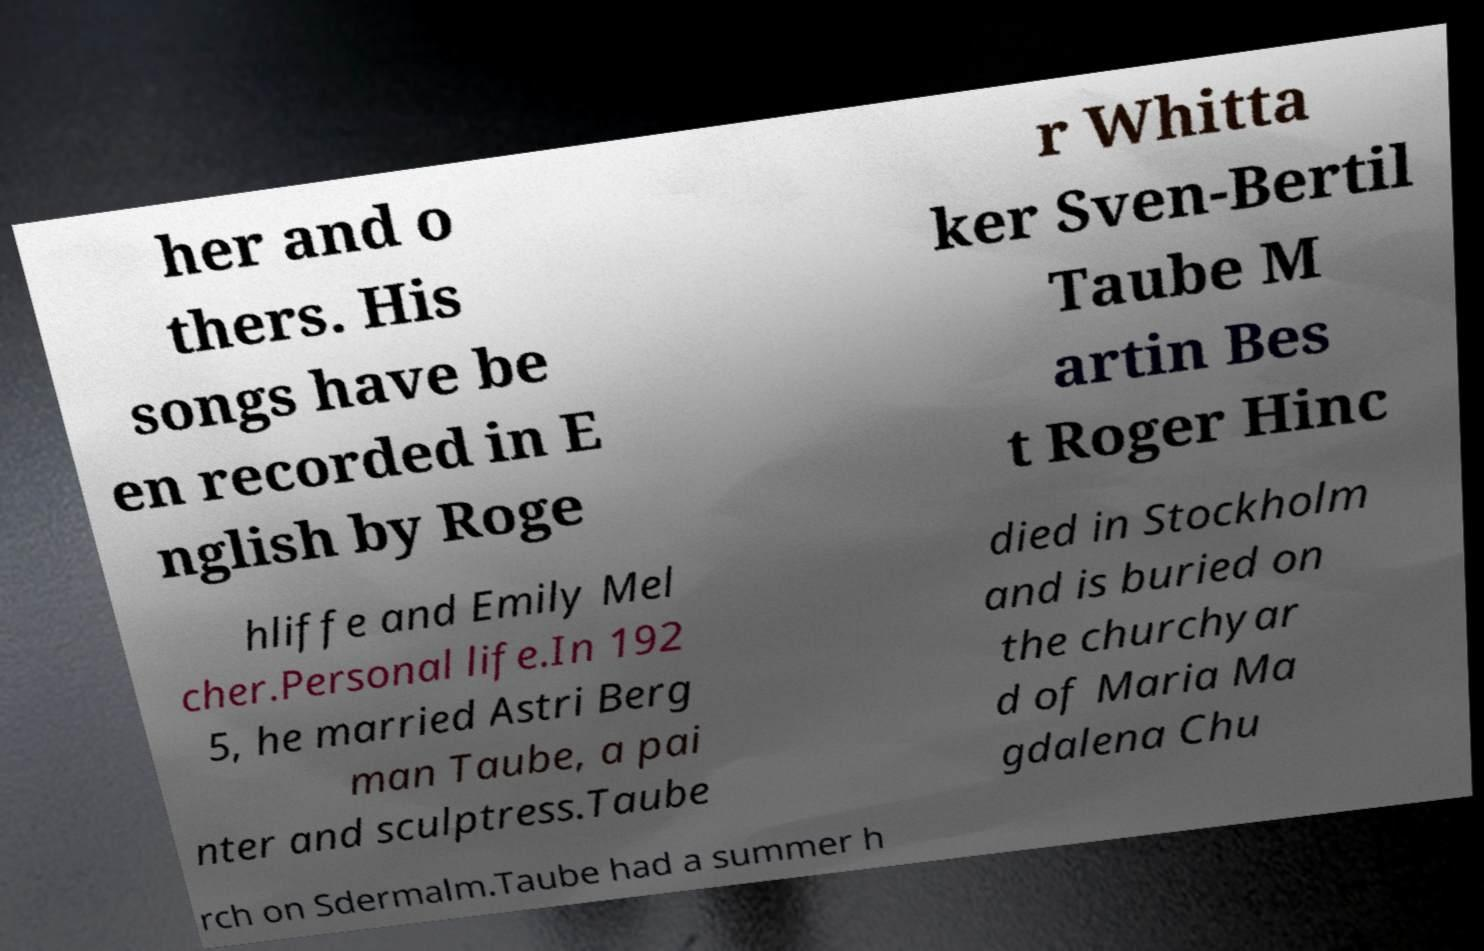Please read and relay the text visible in this image. What does it say? her and o thers. His songs have be en recorded in E nglish by Roge r Whitta ker Sven-Bertil Taube M artin Bes t Roger Hinc hliffe and Emily Mel cher.Personal life.In 192 5, he married Astri Berg man Taube, a pai nter and sculptress.Taube died in Stockholm and is buried on the churchyar d of Maria Ma gdalena Chu rch on Sdermalm.Taube had a summer h 